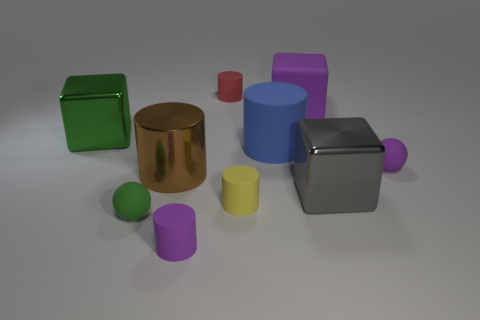Is the number of red objects that are in front of the brown object less than the number of small rubber cylinders that are in front of the large blue thing?
Make the answer very short. Yes. There is another thing that is the same shape as the green rubber thing; what is its color?
Offer a very short reply. Purple. There is a rubber sphere that is behind the green rubber object; is it the same size as the gray object?
Your answer should be very brief. No. Is the number of large gray metallic cubes right of the brown metallic cylinder less than the number of rubber blocks?
Your answer should be compact. No. There is a ball that is in front of the tiny object on the right side of the gray cube; what is its size?
Your response must be concise. Small. Is the number of small red matte cylinders less than the number of brown matte cubes?
Provide a short and direct response. No. What is the tiny cylinder that is both behind the green sphere and in front of the small purple ball made of?
Your response must be concise. Rubber. There is a large metallic cube that is behind the gray metal cube; are there any small green rubber things that are in front of it?
Provide a short and direct response. Yes. How many objects are either large yellow cylinders or large blocks?
Offer a terse response. 3. What shape is the object that is to the left of the large metallic cylinder and on the right side of the green shiny object?
Your answer should be compact. Sphere. 